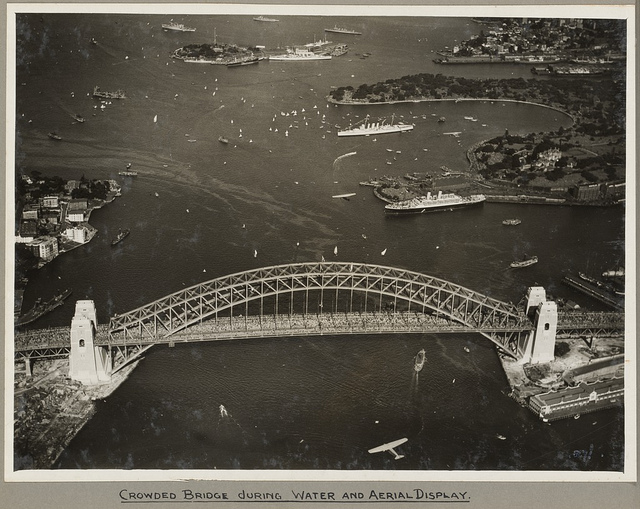Read and extract the text from this image. CROWDED BRIDGE DURING WATER AND DISPLAY AERIAL 